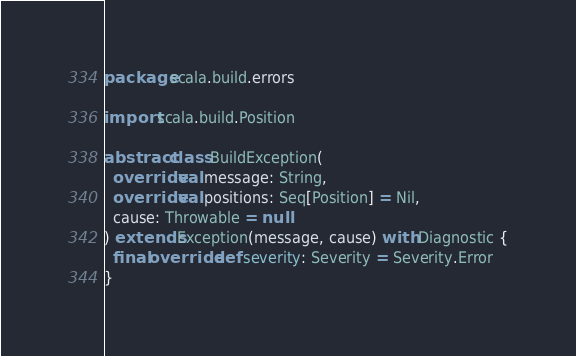Convert code to text. <code><loc_0><loc_0><loc_500><loc_500><_Scala_>package scala.build.errors

import scala.build.Position

abstract class BuildException(
  override val message: String,
  override val positions: Seq[Position] = Nil,
  cause: Throwable = null
) extends Exception(message, cause) with Diagnostic {
  final override def severity: Severity = Severity.Error
}
</code> 